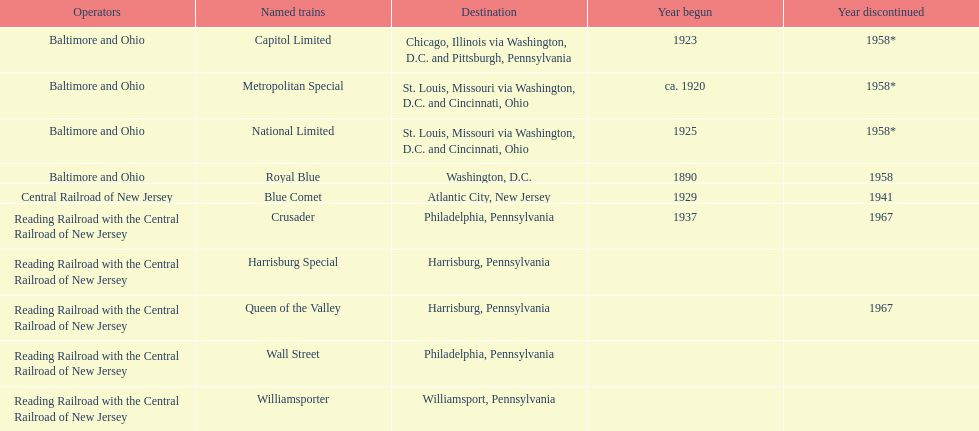Besides wall street, which other train had philadelphia as its destination? Crusader. 